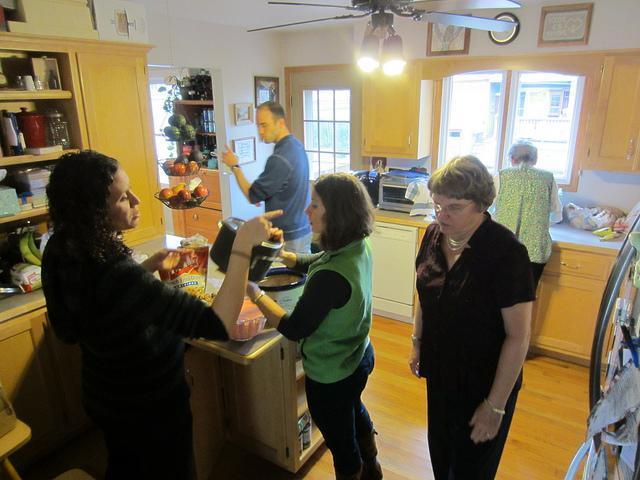How many women are in the room?
Give a very brief answer. 4. How many people are in the picture?
Give a very brief answer. 5. 